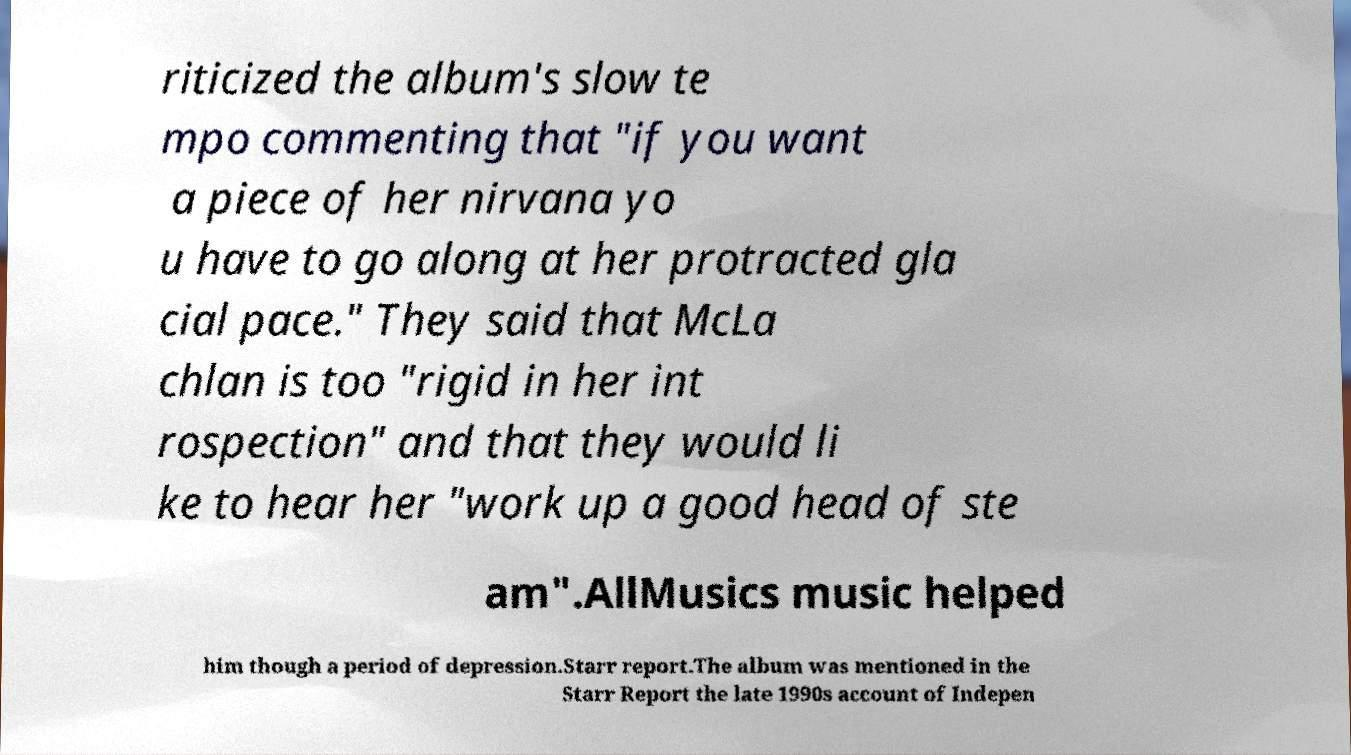Can you read and provide the text displayed in the image?This photo seems to have some interesting text. Can you extract and type it out for me? riticized the album's slow te mpo commenting that "if you want a piece of her nirvana yo u have to go along at her protracted gla cial pace." They said that McLa chlan is too "rigid in her int rospection" and that they would li ke to hear her "work up a good head of ste am".AllMusics music helped him though a period of depression.Starr report.The album was mentioned in the Starr Report the late 1990s account of Indepen 